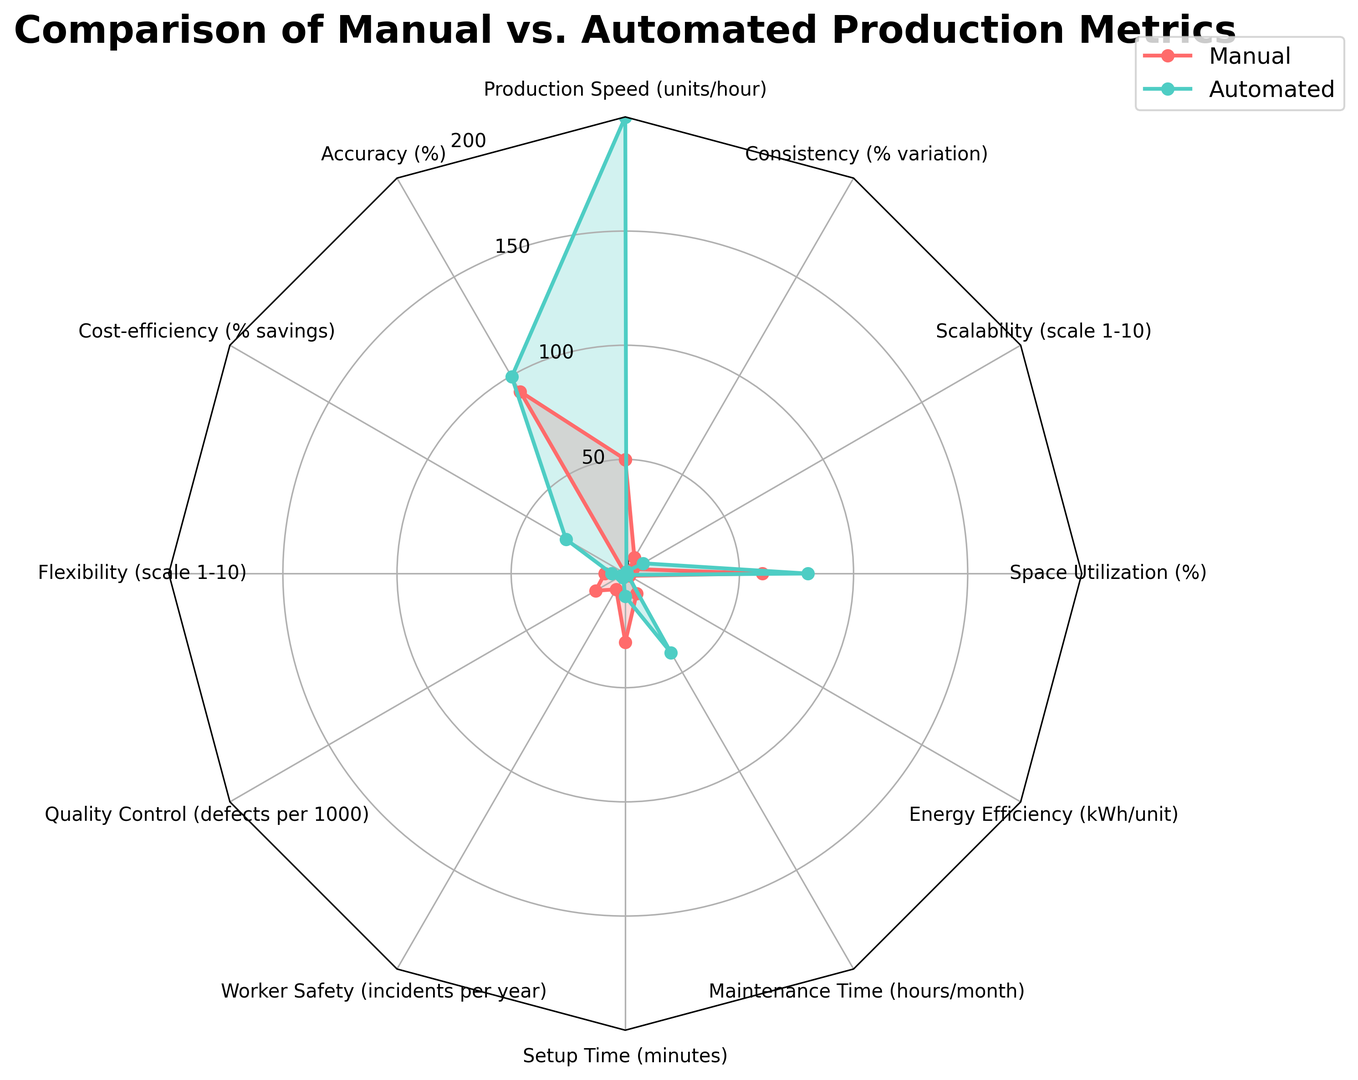What's the difference in production speed between manual and automated systems? The radar chart shows that the production speed for manual systems is 50 units per hour and for automated systems, it's 200 units per hour. Subtract the manual speed from the automated speed: 200 - 50 = 150 units per hour.
Answer: 150 units per hour Which production type has a higher accuracy, and by how much? The radar chart illustrates the accuracy for manual systems is 92%, and for automated systems, it's 99.5%. Subtract the manual accuracy from the automated accuracy: 99.5% - 92% = 7.5%.
Answer: Automated, by 7.5% How do the maintenance times compare between manual and automated production? From the radar chart, the maintenance time for manual production is 10 hours per month, while for automated production, it's 40 hours per month. Automated maintenance time is 40 - 10 = 30 hours more than manual maintenance.
Answer: Automated requires 30 more hours Which type of production is more cost-efficient? Reviewing the radar chart, the cost-efficiency is 0% for manual production and 30% for automated production, making automated production more cost-efficient.
Answer: Automated production What's the difference in worker safety incidents per year between manual and automated production? The radar chart displays worker safety incidents per year as 8 for manual production and 2 for automated production. The difference is 8 - 2 = 6 incidents.
Answer: 6 incidents Which production type utilizes space more effectively? The radar chart shows space utilization at 60% for manual production and 80% for automated production, indicating that automated production utilizes space more effectively.
Answer: Automated production How does flexibility compare between manual and automated production? According to the radar chart, flexibility is rated as 9 for manual production and 6 for automated production. Therefore, manual production is more flexible by 9 - 6 = 3 units.
Answer: Manual production, by 3 units What's the sum of the accuracy percentages for both manual and automated production systems? From the radar chart, the accuracy for manual is 92% and for automated, it's 99.5%. Adding these two values together: 92% + 99.5% = 191.5%.
Answer: 191.5% Which type of production has better quality control, and what's the difference in defects per 1000? The radar chart shows quality control as 15 defects per 1000 for manual production and 2 defects per 1000 for automated production. Subtracting the automated defects from manual defects: 15 - 2 = 13 defects.
Answer: Automated, by 13 defects 